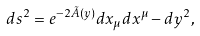<formula> <loc_0><loc_0><loc_500><loc_500>d s ^ { 2 } = e ^ { - 2 \tilde { A } ( y ) } d x _ { \mu } d x ^ { \mu } - d y ^ { 2 } ,</formula> 